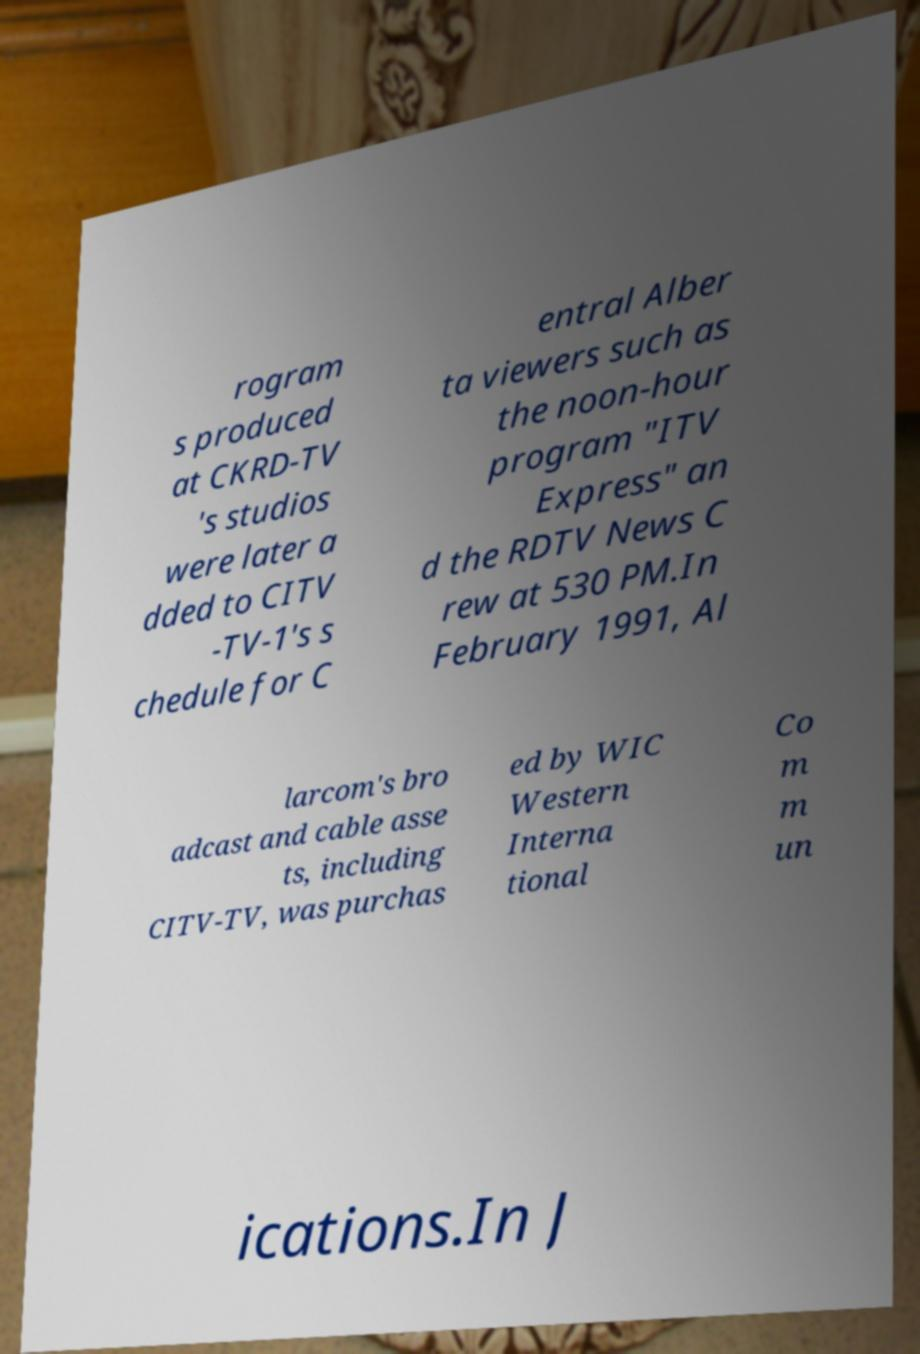Could you assist in decoding the text presented in this image and type it out clearly? rogram s produced at CKRD-TV 's studios were later a dded to CITV -TV-1's s chedule for C entral Alber ta viewers such as the noon-hour program "ITV Express" an d the RDTV News C rew at 530 PM.In February 1991, Al larcom's bro adcast and cable asse ts, including CITV-TV, was purchas ed by WIC Western Interna tional Co m m un ications.In J 